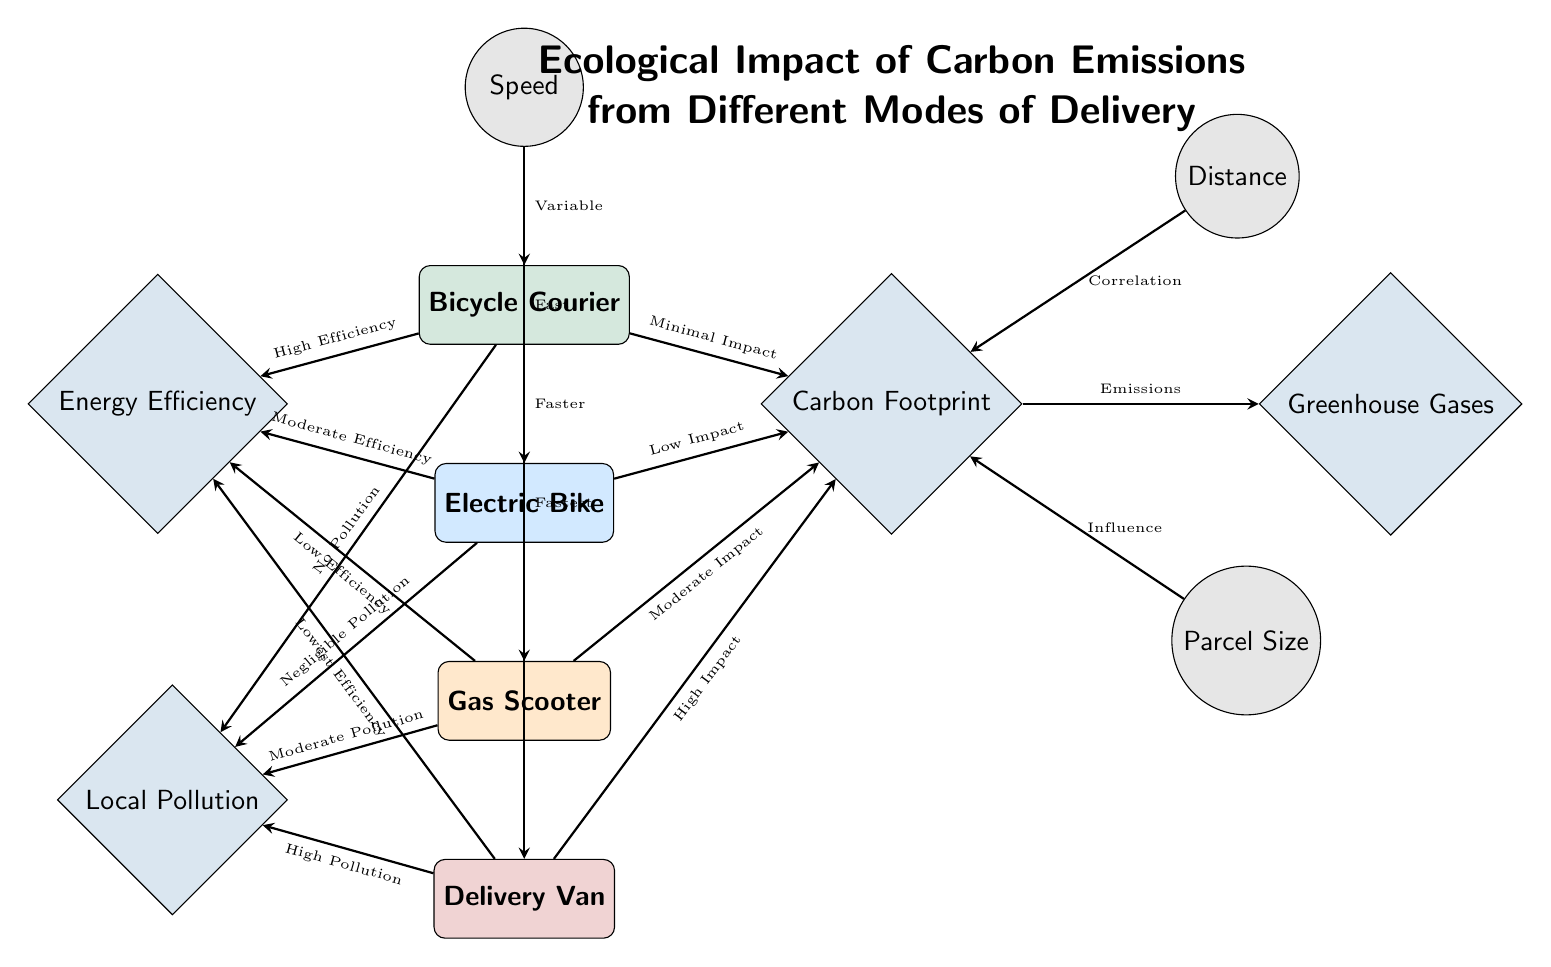What is the environmental impact of a Bicycle Courier? The diagram indicates that a Bicycle Courier has "Minimal Impact" on the carbon footprint, which suggests low carbon emissions associated with this mode of delivery.
Answer: Minimal Impact Which mode of delivery has the highest carbon footprint impact? According to the connections in the diagram, the Delivery Van is indicated to have "High Impact" on the carbon footprint, making it the highest compared to other modes.
Answer: High Impact What relationship does distance have with carbon footprint? The diagram shows an arrow labeled "Correlation" pointing from the distance node to the carbon footprint node, indicating that there is a relationship where distance influences the carbon emissions.
Answer: Correlation How does the Energy Efficiency of a Gas Scooter compare to a Bicycle Courier? The diagram shows that the Gas Scooter has "Low Efficiency" while the Bicycle Courier has "High Efficiency," indicating that the latter is more energy efficient.
Answer: Low Efficiency vs High Efficiency Which mode of delivery produces the least local pollution? The diagram states that the Bicycle Courier produces "No Pollution," which indicates it has the least local pollution compared to other modes of delivery.
Answer: No Pollution What factors influence the carbon footprint besides mode of delivery? Two factors are indicated in the diagram that influence carbon footprint: "Distance" and "Parcel Size," showing that both can impact emissions levels.
Answer: Distance, Parcel Size Which mode of delivery is associated with the lowest greenhouse gas emissions? The Bicycle Courier is linked to "Minimal Impact" on the carbon footprint, which typically correlates with the lowest emissions of greenhouse gases compared to other delivery modes.
Answer: Minimal Impact What is the impact of an Electric Bike on local pollution? The diagram shows that the Electric Bike has "Negligible Pollution," indicating it has low local pollution impact compared to other delivery options.
Answer: Negligible Pollution Which mode of delivery is the fastest according to the speed factors? The Delivery Van is described as "Fastest," which indicates that among the listed modes, it has the highest speed capability.
Answer: Fastest 